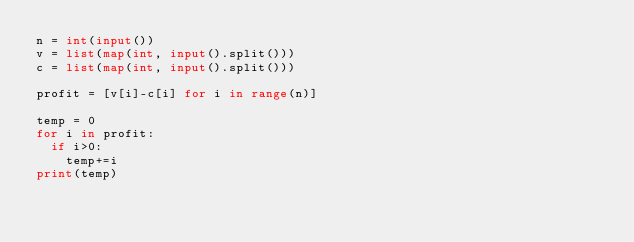<code> <loc_0><loc_0><loc_500><loc_500><_Python_>n = int(input())
v = list(map(int, input().split()))
c = list(map(int, input().split()))

profit = [v[i]-c[i] for i in range(n)]

temp = 0
for i in profit:
  if i>0:
  	temp+=i
print(temp)</code> 